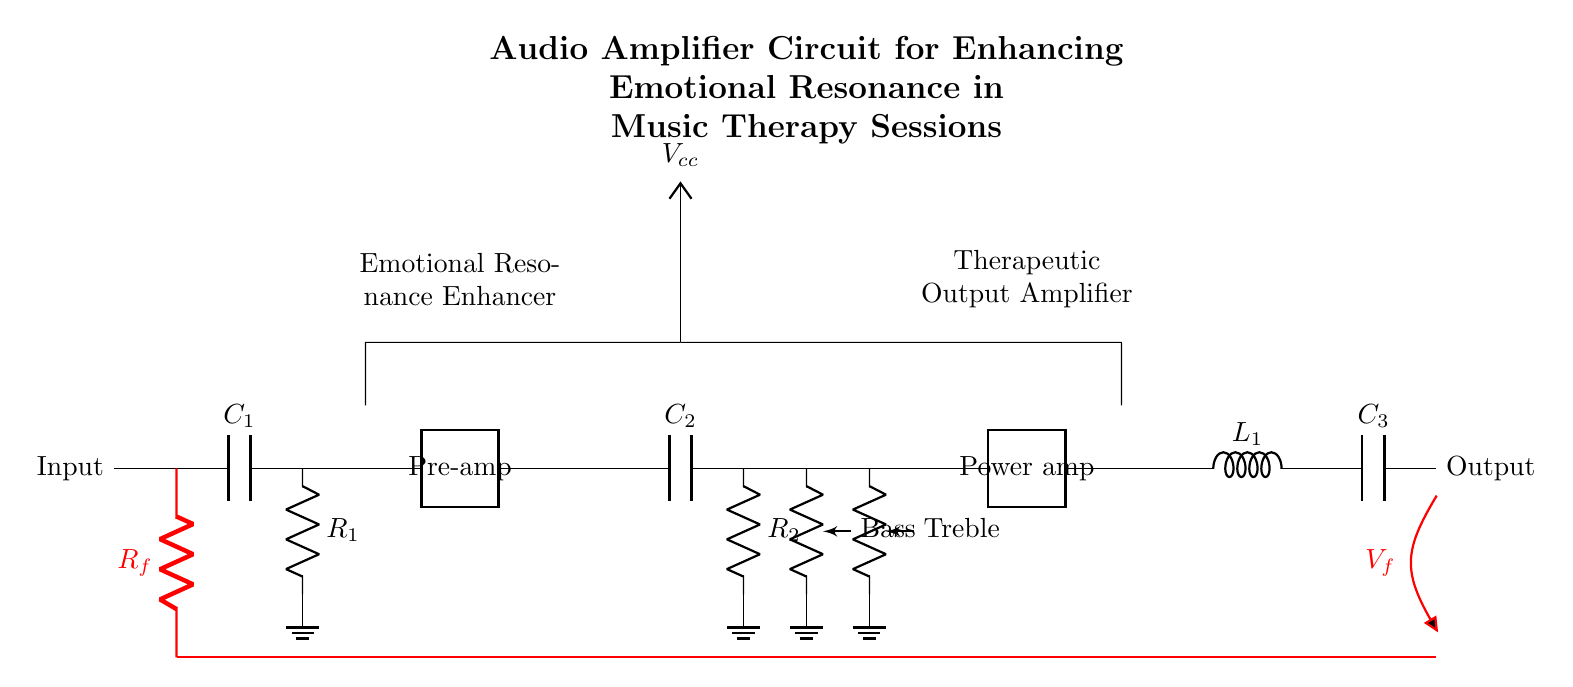What is the value of the capacitor in the input stage? The capacitor in the input stage is labeled as C1, but the specific value isn't indicated directly in the circuit. However, generally in audio circuits, these capacitors might range widely depending on the design.
Answer: Not specified What component is used for power amplification? The circuit includes a section labeled as "Power amp", indicating that two-port amplifiers are used for power amplification. This is a common component type in audio amplification to increase the output power significantly.
Answer: Power amp What type of filter does the tone control stage implement? The tone control stage employs capacitors and resistors to adjust the bass and treble frequencies. By modifying the impedance at these stages, it effectively creates low-pass and high-pass filters to control frequency response.
Answer: Bass and Treble control How does feedback influence this circuit? The circuit implements a feedback loop represented by a red line connecting the output back to the input through a resistor labeled Rf. Feedback helps stabilize the gain and improve the linearity of the amplifier by reducing distortion and optimizing performance.
Answer: Feedback loop What is the purpose of capacitor C3 in the output stage? Capacitor C3 is designed for coupling or decoupling in the output stage. It blocks any DC offset while allowing the AC audio signal to pass through effectively, ensuring that only the audio signal is delivered without unwanted DC components.
Answer: Coupling Capacitor Which component grounds the output of the power amplifier? The output from the power amplifier stages connects to an inductor (L1) and then to another capacitor (C3), where the energy is finally grounded. This is important for establishing a reference point in the circuit and ensuring stability.
Answer: Inductor (L1) What is the role of the pre-amplifier? The pre-amplifier is crucial for boosting weak audio signals from the input stage to a level suitable for processing in further stages of the amplifier. It enhances the signal's strength while maintaining fidelity, which is critical for emotional resonance in music therapy.
Answer: Boosting weak signals 